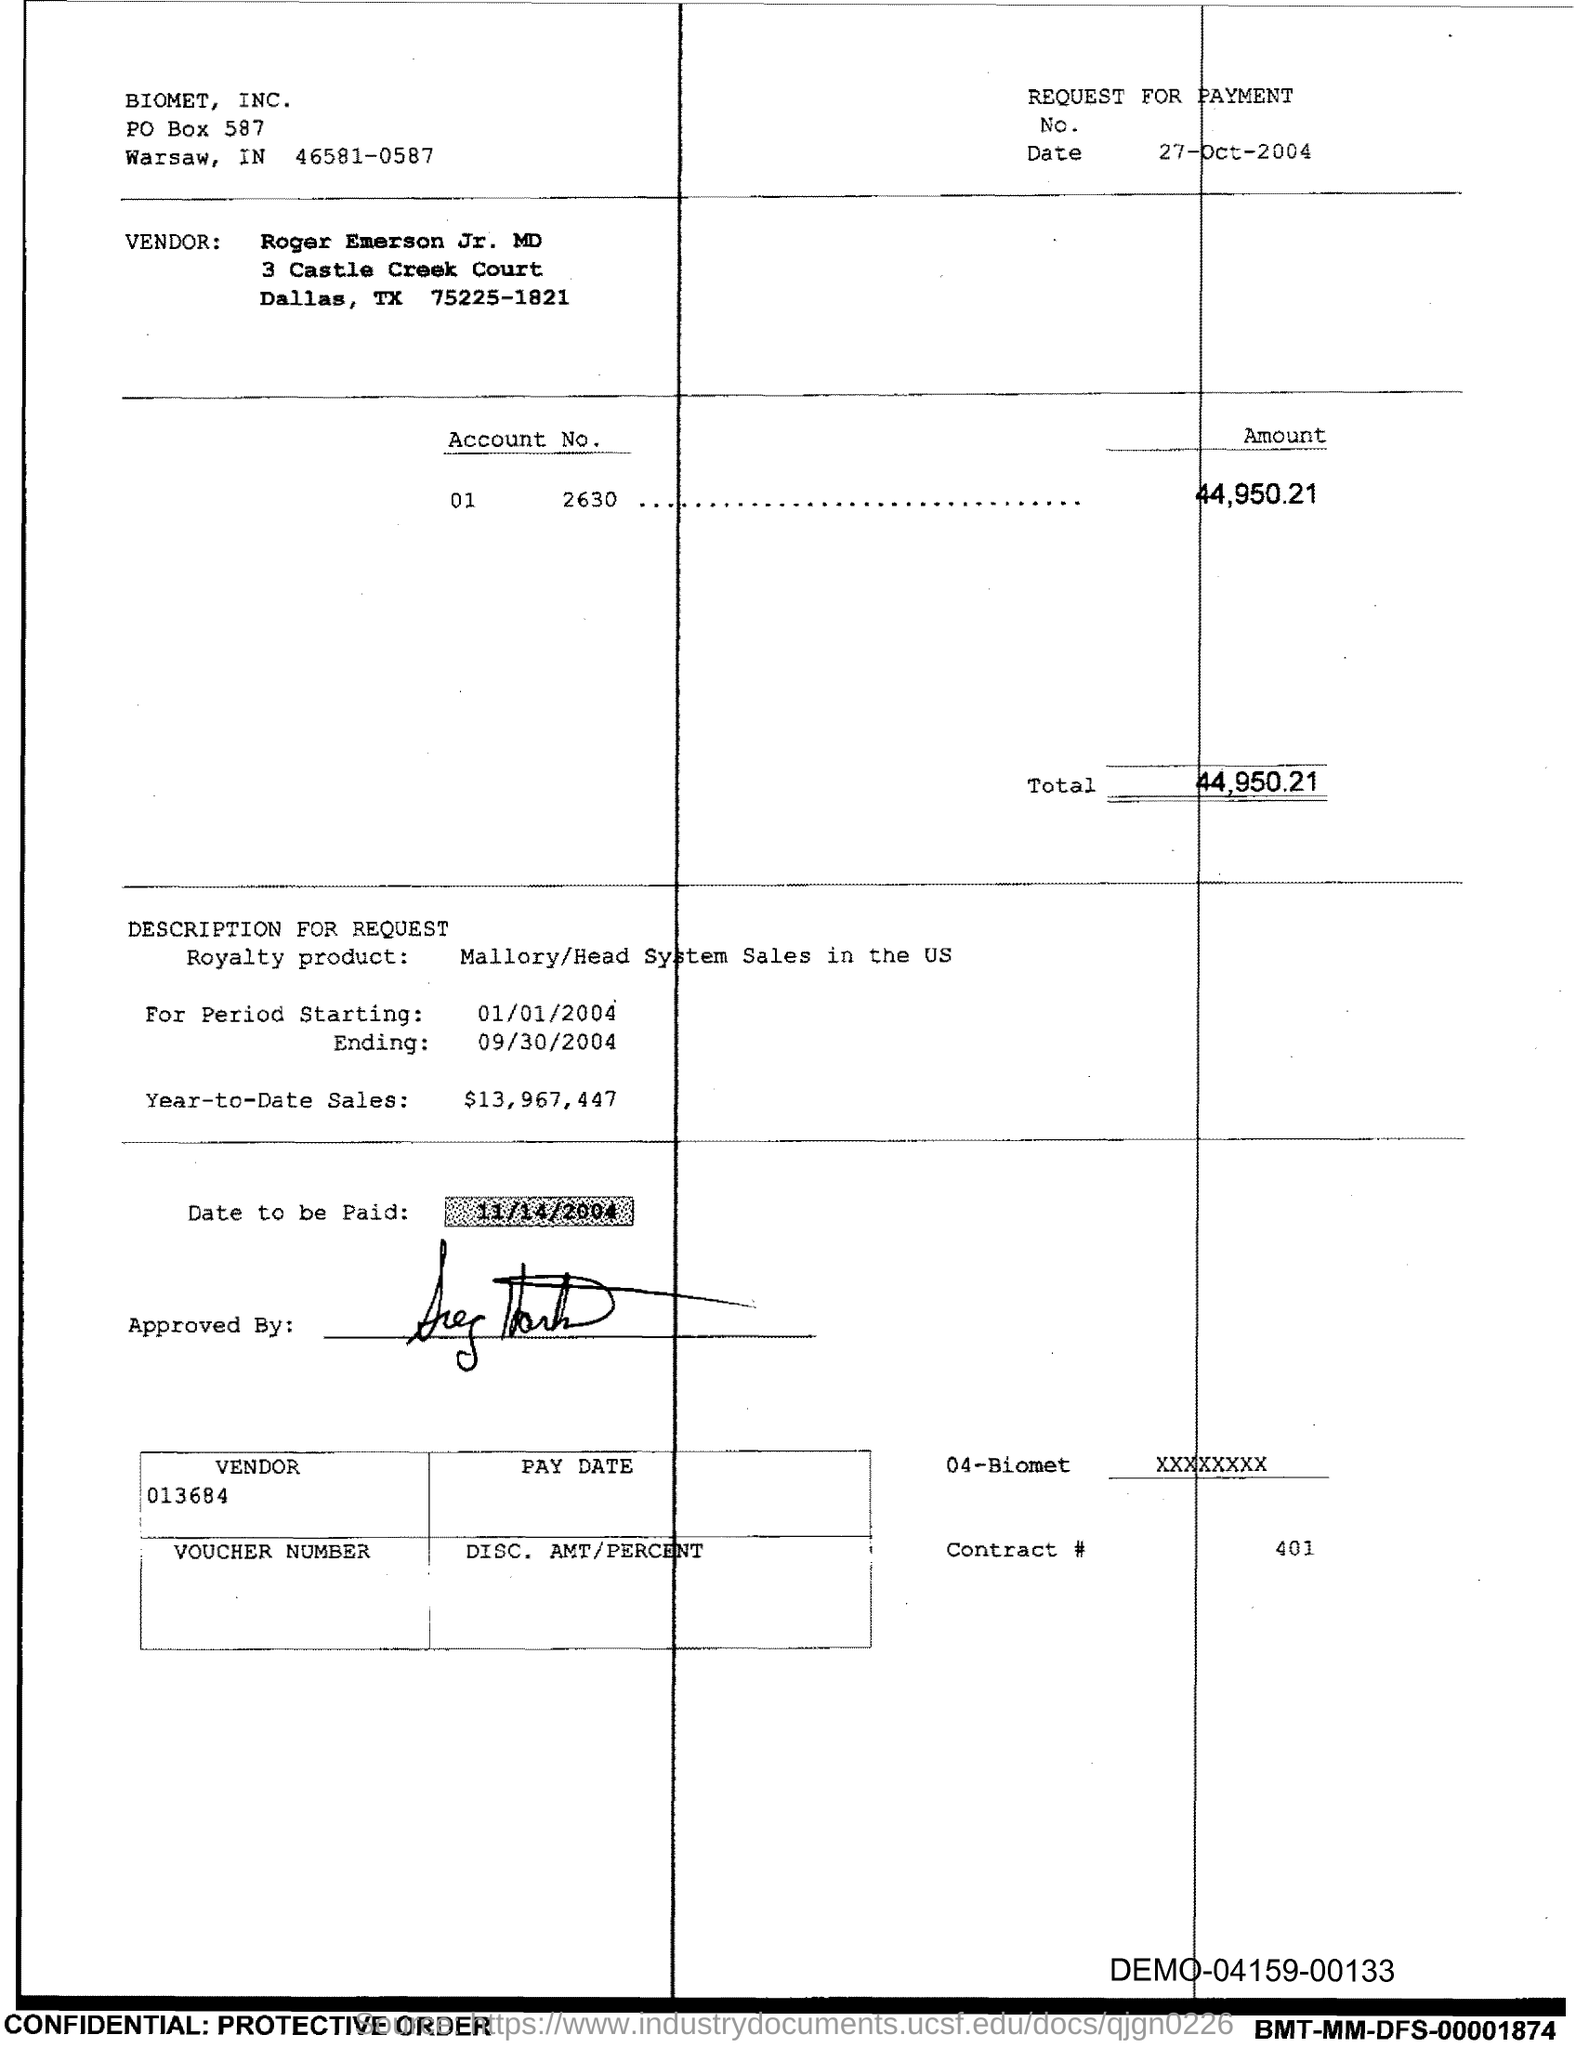Specify some key components in this picture. The Contract # Number is 401. The total amount is 44,950.21. 